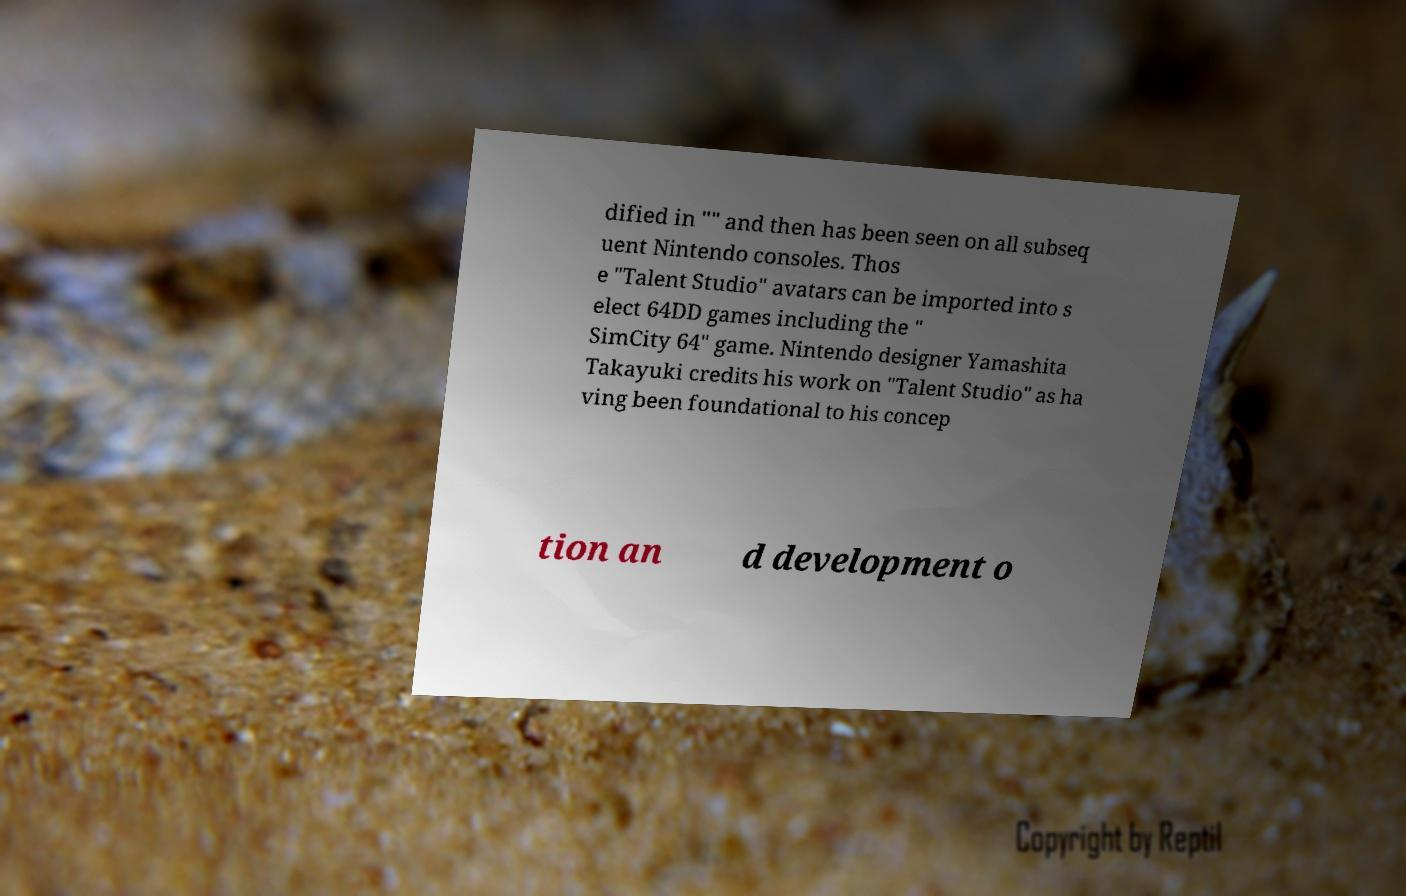Could you assist in decoding the text presented in this image and type it out clearly? dified in "" and then has been seen on all subseq uent Nintendo consoles. Thos e "Talent Studio" avatars can be imported into s elect 64DD games including the " SimCity 64" game. Nintendo designer Yamashita Takayuki credits his work on "Talent Studio" as ha ving been foundational to his concep tion an d development o 